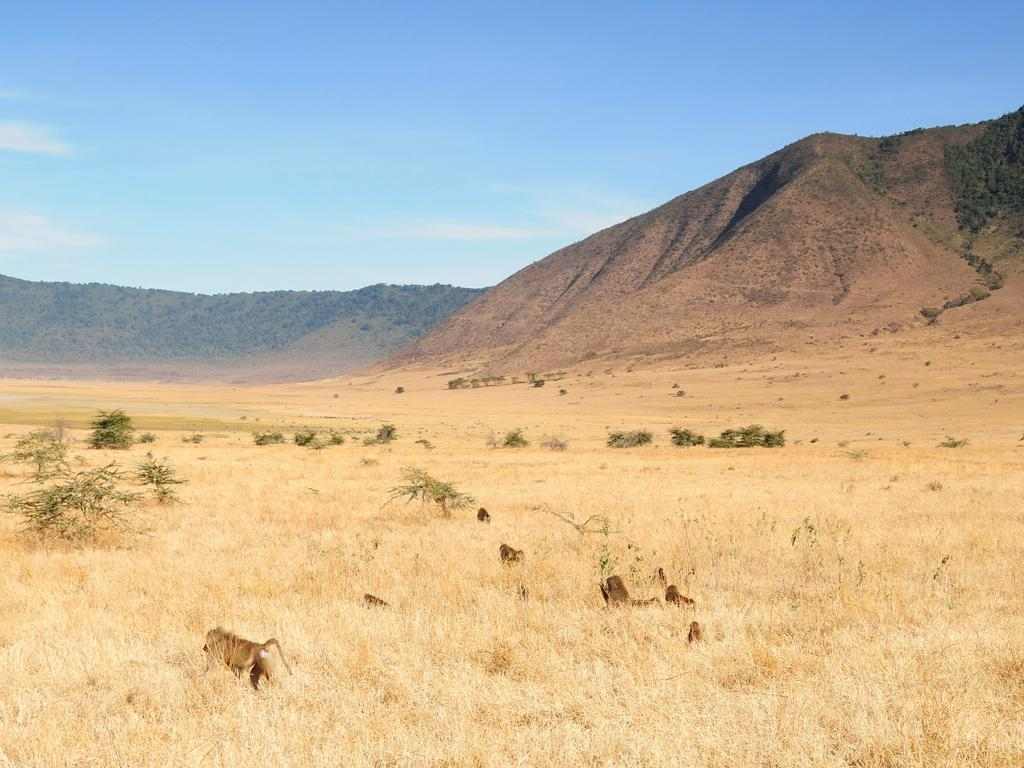What type of vegetation is present on the ground in the image? There is dried grass on the ground in the image. What other subjects can be seen in the image? There are animals in the image. What geographical feature is located on the right side of the image? There is a mountain on the right side of the image. What color is the sky in the image? The sky is blue in the image. What type of crime is being committed in the image? There is no crime being committed in the image; it features dried grass, animals, a mountain, and a blue sky. What view can be seen from the top of the mountain in the image? The image does not show a view from the top of the mountain, as it only depicts the mountain's side. 